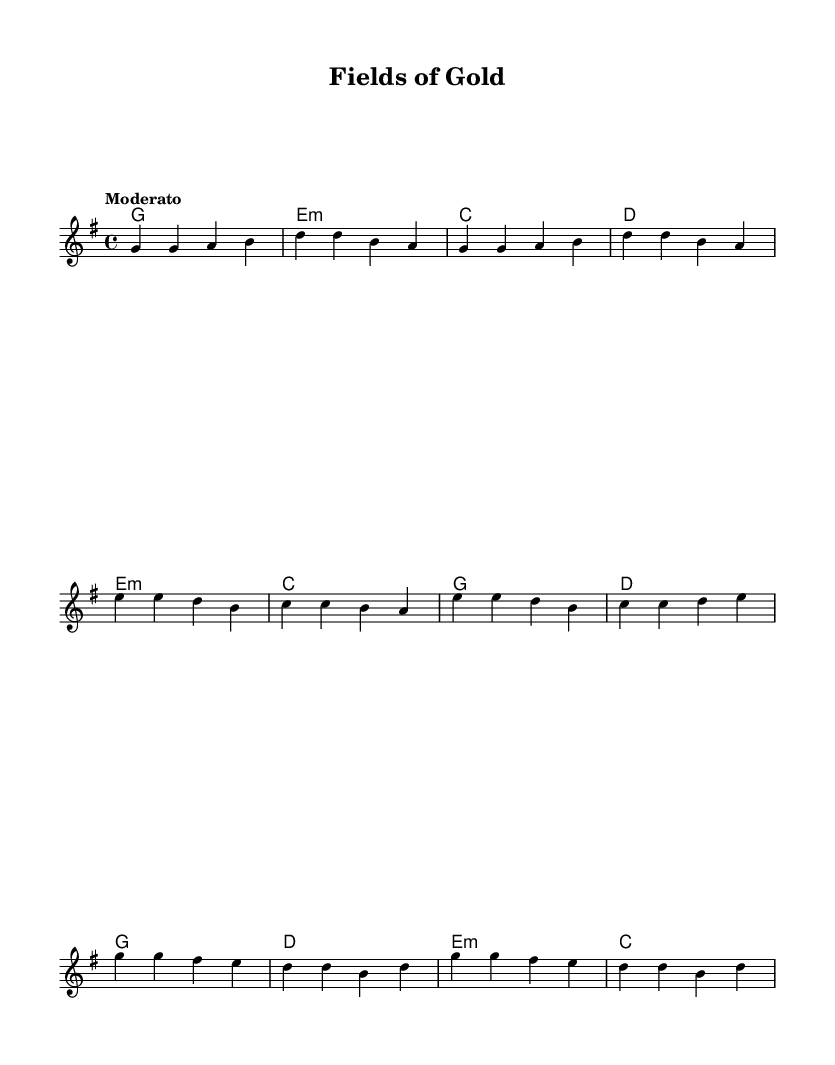What is the key signature of this music? The key signature is G major, which has one sharp (F#). This can be determined by looking at the key signature notation at the beginning of the staff.
Answer: G major What is the time signature of this music? The time signature is 4/4, indicated at the beginning of the score. This means there are four beats in each measure and a quarter note receives one beat.
Answer: 4/4 What is the tempo marking for this piece? The tempo marking is "Moderato," which suggests a moderate speed for the piece. This is typically indicated in words at the beginning of the score under tempo markings.
Answer: Moderato How many measures are in the verse section? The verse section contains four measures, as indicated by the grouping and layout of notes. Each group of notes within the verse brackets indicates a measure.
Answer: 4 What chords are played during the pre-chorus? The chords during the pre-chorus are E minor, C major, G major, and D major. These can be seen directly in the chord names aligned with the corresponding melody notes in the pre-chorus section of the score.
Answer: E minor, C, G, D In what section does the melody first introduce a tempo change? The melody does not introduce a tempo change, as the only tempo marking provided is "Moderato," and it remains consistent throughout. Therefore, no sections indicate a change in tempo.
Answer: No section What type of song structure is present in this piece? The song structure is typical of a verse-pre-chorus-chorus layout, which is common in R&B music. This can be seen from the arrangement of the melody and choruses indicated across the different sections of the score.
Answer: Verse-pre-chorus-chorus 